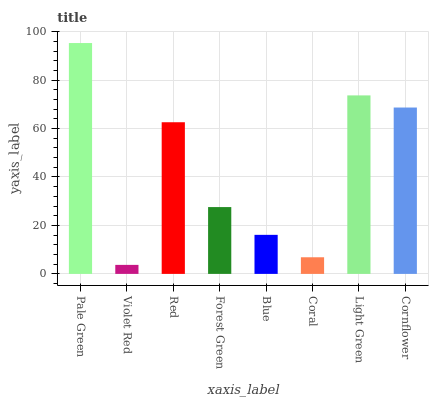Is Violet Red the minimum?
Answer yes or no. Yes. Is Pale Green the maximum?
Answer yes or no. Yes. Is Red the minimum?
Answer yes or no. No. Is Red the maximum?
Answer yes or no. No. Is Red greater than Violet Red?
Answer yes or no. Yes. Is Violet Red less than Red?
Answer yes or no. Yes. Is Violet Red greater than Red?
Answer yes or no. No. Is Red less than Violet Red?
Answer yes or no. No. Is Red the high median?
Answer yes or no. Yes. Is Forest Green the low median?
Answer yes or no. Yes. Is Forest Green the high median?
Answer yes or no. No. Is Cornflower the low median?
Answer yes or no. No. 